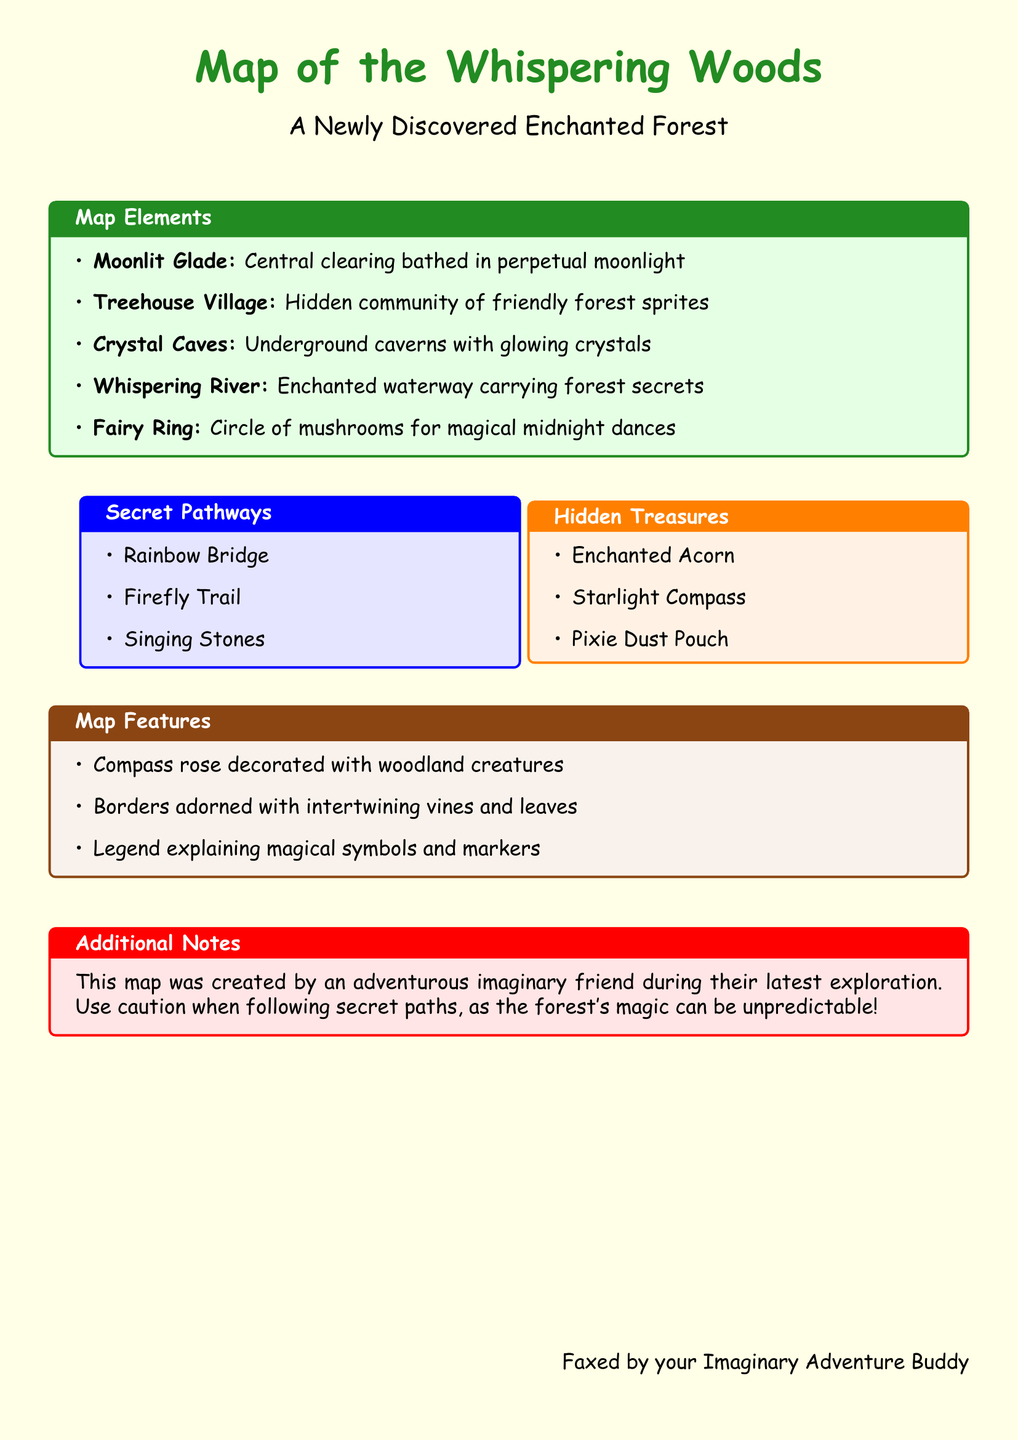What is the title of the map? The title of the map is indicated prominently at the top of the document as "Map of the Whispering Woods."
Answer: Map of the Whispering Woods What color is the highlighting around the map elements? The highlighting around the map elements is shown in green, indicated by the color setting in the document.
Answer: Green Name one hidden treasure listed on the map. A hidden treasure listed on the map is mentioned within the corresponding section, stating items like "Enchanted Acorn."
Answer: Enchanted Acorn How many secret pathways are detailed in the document? The document lists three secret pathways under the specific section for secret pathways, making it a direct count.
Answer: Three What is the setting of this newly discovered place? The setting mentioned in the document indicates that the map represents an "Enchanted Forest."
Answer: Enchanted Forest Who faxed this document? The document concludes with a note indicating it was faxed by the "Imaginary Adventure Buddy."
Answer: Imaginary Adventure Buddy What type of creatures adorn the compass rose? The compass rose is said to be decorated with "woodland creatures," as described in the relevant section of the map features.
Answer: Woodland creatures What caution is advised regarding the secret paths? The document includes a note advising to "use caution," suggesting that the paths have unpredictable characteristics.
Answer: Use caution 